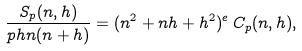<formula> <loc_0><loc_0><loc_500><loc_500>\frac { S _ { p } ( n , h ) } { p h n ( n + h ) } = ( n ^ { 2 } + n h + h ^ { 2 } ) ^ { e } \, C _ { p } ( n , h ) ,</formula> 